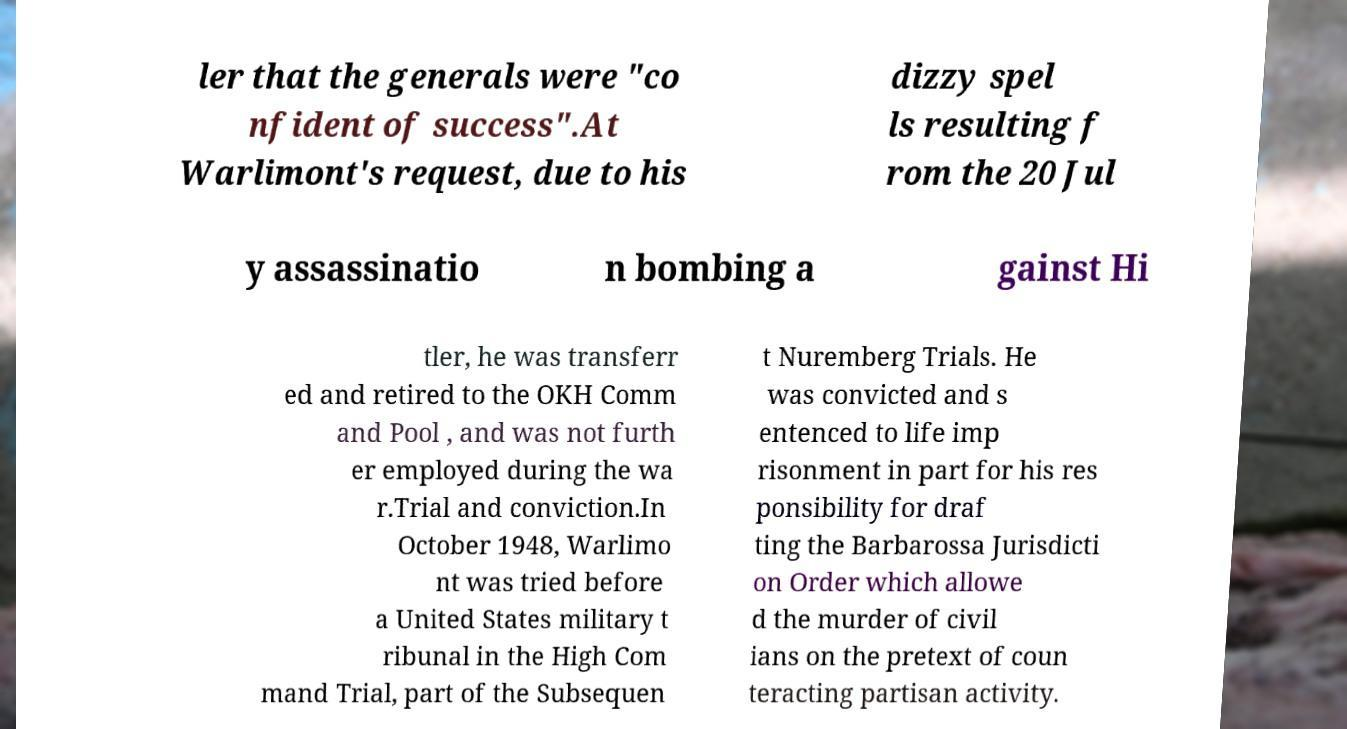What messages or text are displayed in this image? I need them in a readable, typed format. ler that the generals were "co nfident of success".At Warlimont's request, due to his dizzy spel ls resulting f rom the 20 Jul y assassinatio n bombing a gainst Hi tler, he was transferr ed and retired to the OKH Comm and Pool , and was not furth er employed during the wa r.Trial and conviction.In October 1948, Warlimo nt was tried before a United States military t ribunal in the High Com mand Trial, part of the Subsequen t Nuremberg Trials. He was convicted and s entenced to life imp risonment in part for his res ponsibility for draf ting the Barbarossa Jurisdicti on Order which allowe d the murder of civil ians on the pretext of coun teracting partisan activity. 